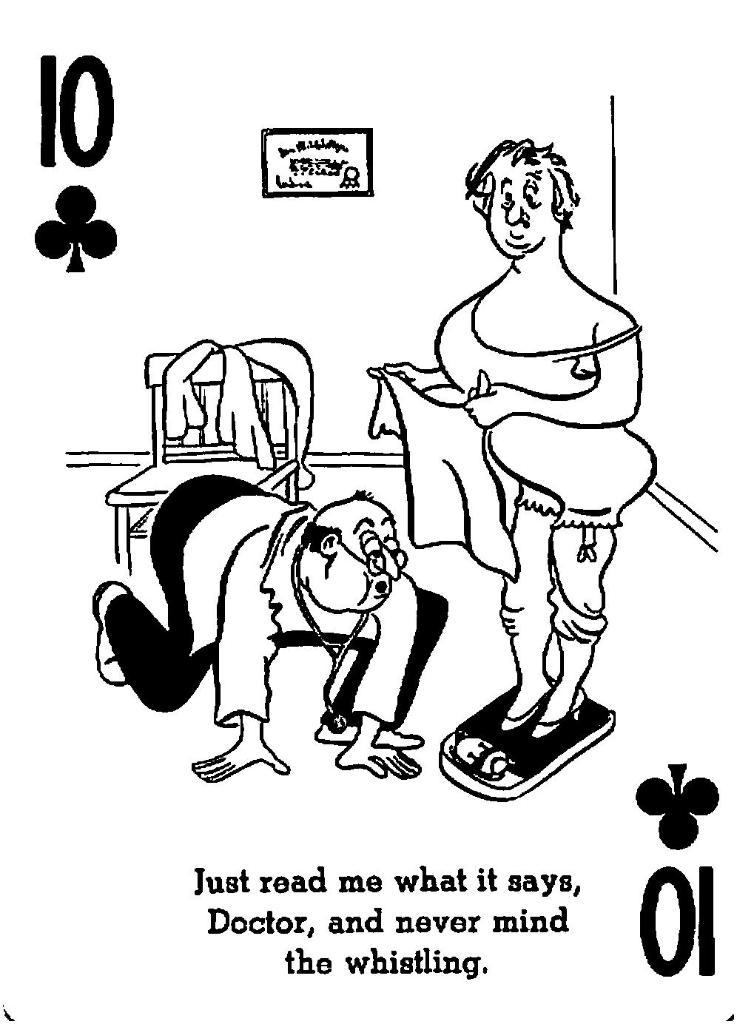What is depicted on the poster in the image? The poster contains drawings of two persons, cloth, and a chair. What else can be found on the poster besides the drawings? There is text, numbers, and signs on the poster. Can you hear the sock crying in the image? There is no sock present in the image, and therefore no crying can be heard. 